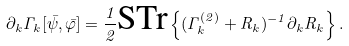<formula> <loc_0><loc_0><loc_500><loc_500>\partial _ { k } \Gamma _ { k } [ \bar { \psi } , \bar { \varphi } ] = \frac { 1 } { 2 } \text {STr} \left \{ ( \Gamma _ { k } ^ { ( 2 ) } + R _ { k } ) ^ { - 1 } \partial _ { k } R _ { k } \right \} .</formula> 